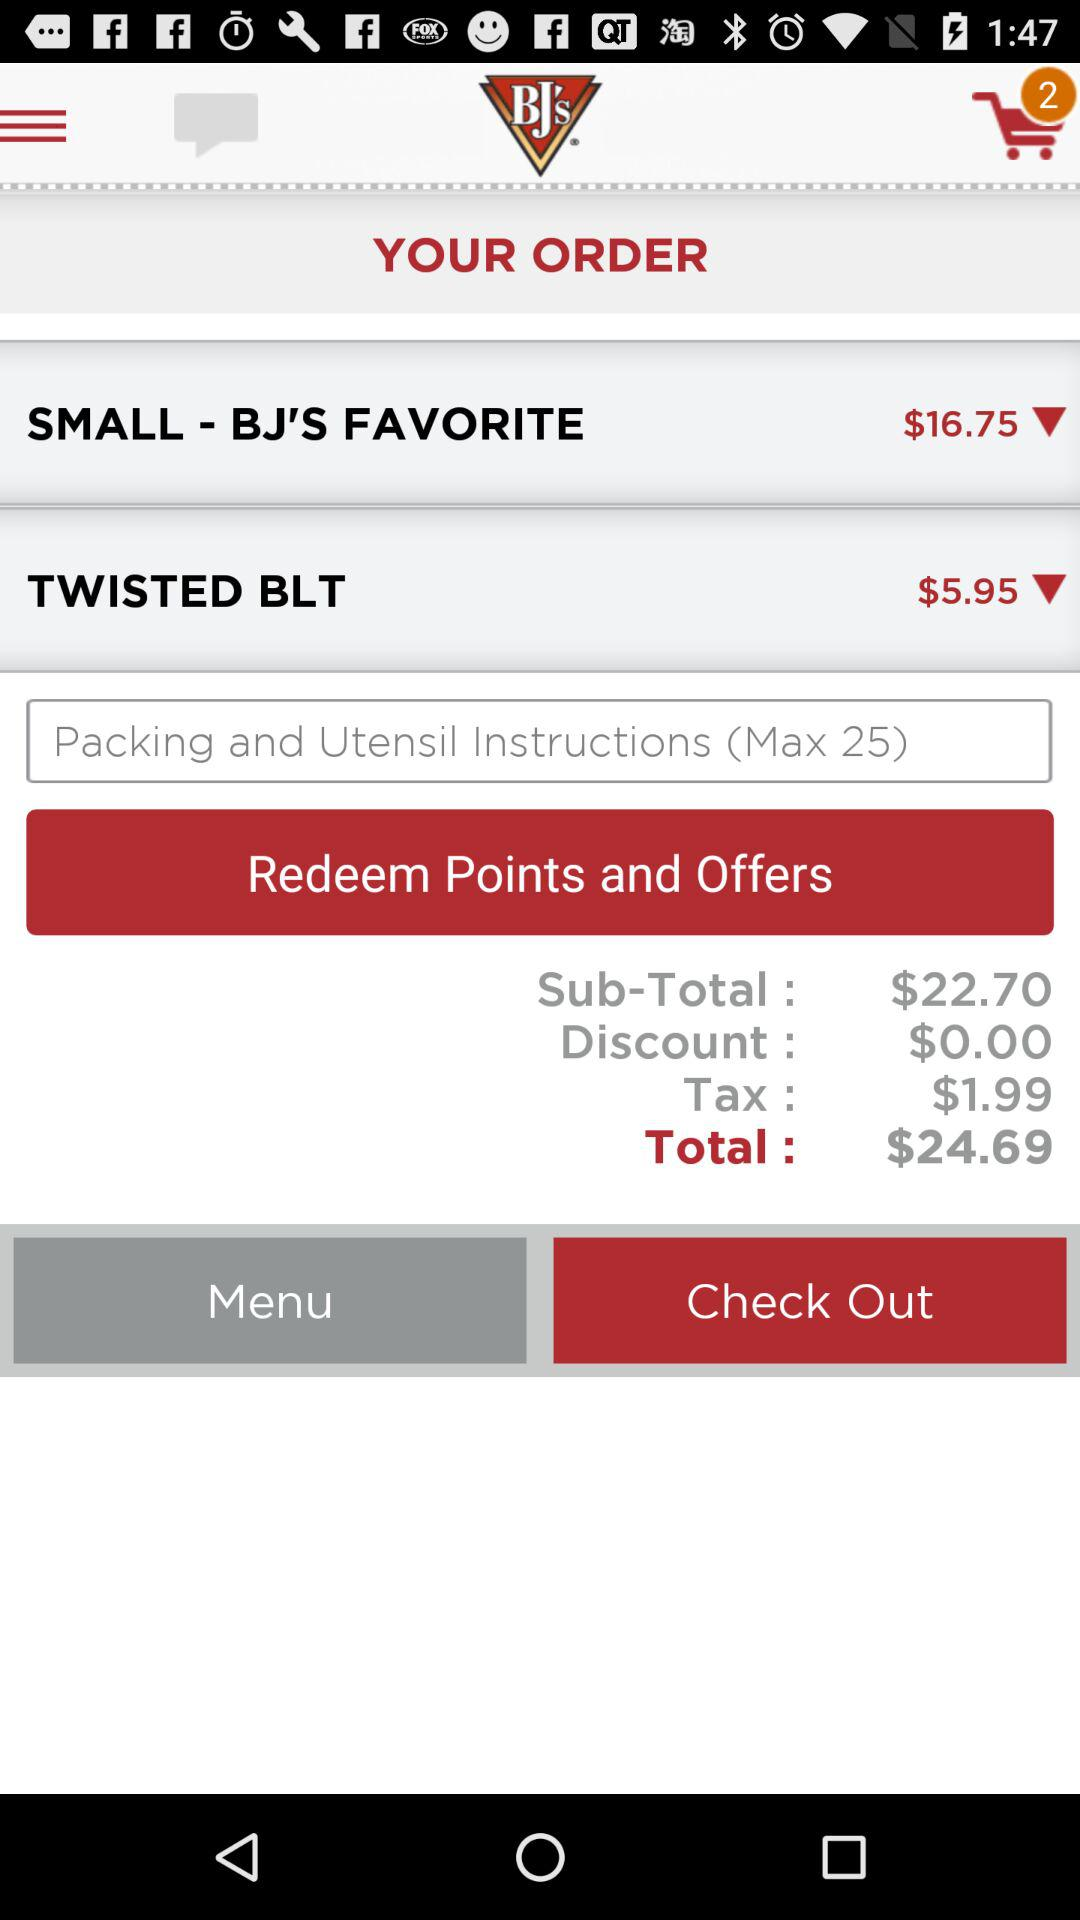How much is the total price? The total price is $24.69. 